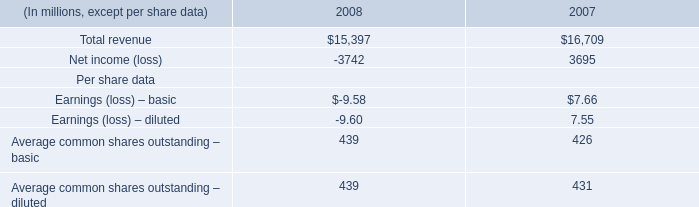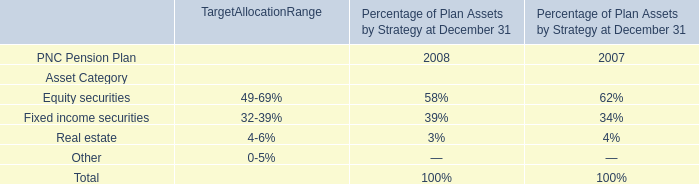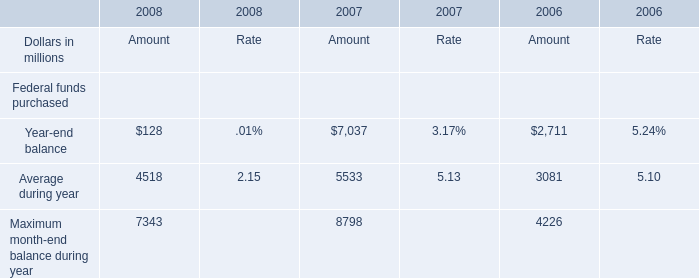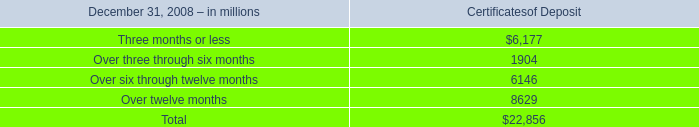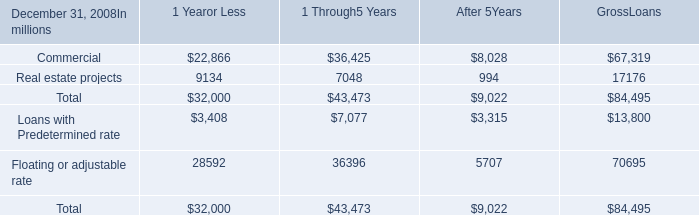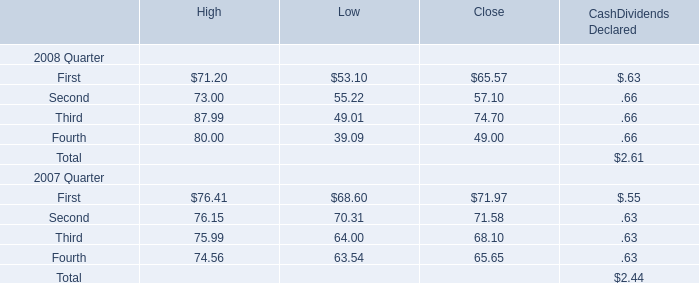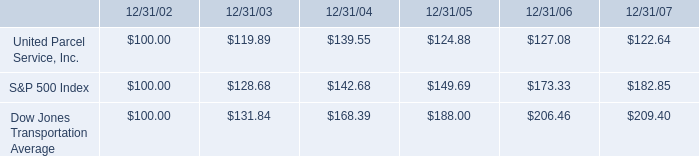What is the proportion of all elements that are greater than 6000 to the total amount of elements in 2008? 
Computations: (((6177 + 6146) + 8629) / 22856)
Answer: 0.9167. 